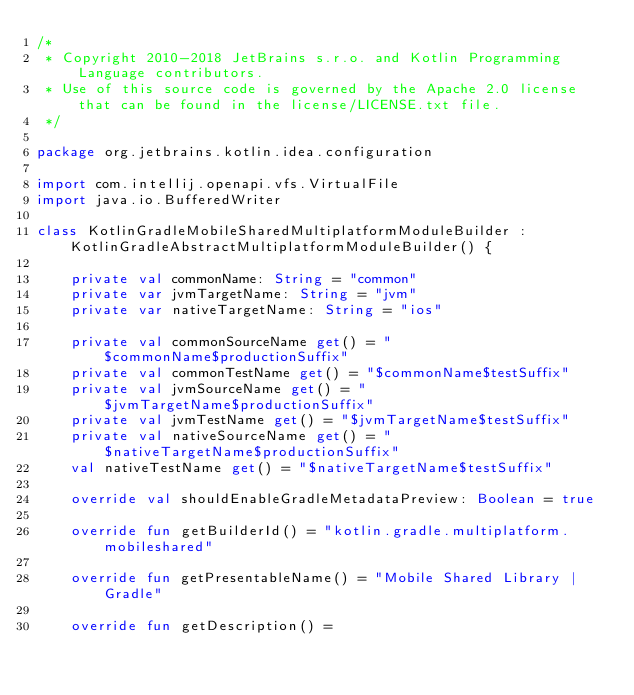Convert code to text. <code><loc_0><loc_0><loc_500><loc_500><_Kotlin_>/*
 * Copyright 2010-2018 JetBrains s.r.o. and Kotlin Programming Language contributors.
 * Use of this source code is governed by the Apache 2.0 license that can be found in the license/LICENSE.txt file.
 */

package org.jetbrains.kotlin.idea.configuration

import com.intellij.openapi.vfs.VirtualFile
import java.io.BufferedWriter

class KotlinGradleMobileSharedMultiplatformModuleBuilder : KotlinGradleAbstractMultiplatformModuleBuilder() {

    private val commonName: String = "common"
    private var jvmTargetName: String = "jvm"
    private var nativeTargetName: String = "ios"

    private val commonSourceName get() = "$commonName$productionSuffix"
    private val commonTestName get() = "$commonName$testSuffix"
    private val jvmSourceName get() = "$jvmTargetName$productionSuffix"
    private val jvmTestName get() = "$jvmTargetName$testSuffix"
    private val nativeSourceName get() = "$nativeTargetName$productionSuffix"
    val nativeTestName get() = "$nativeTargetName$testSuffix"

    override val shouldEnableGradleMetadataPreview: Boolean = true

    override fun getBuilderId() = "kotlin.gradle.multiplatform.mobileshared"

    override fun getPresentableName() = "Mobile Shared Library | Gradle"

    override fun getDescription() =</code> 